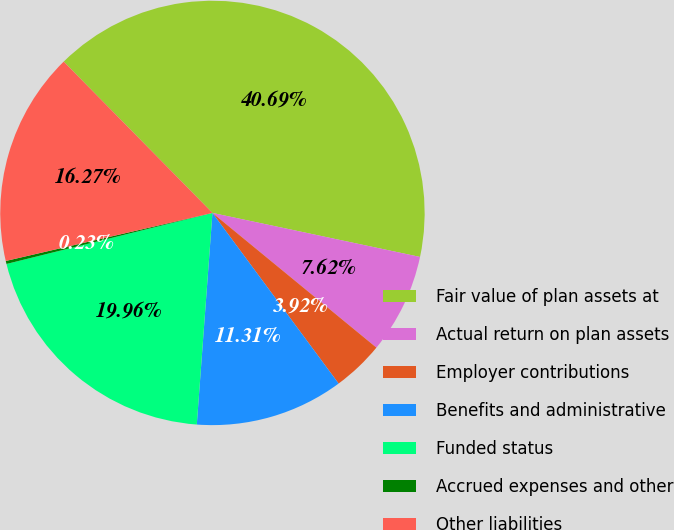<chart> <loc_0><loc_0><loc_500><loc_500><pie_chart><fcel>Fair value of plan assets at<fcel>Actual return on plan assets<fcel>Employer contributions<fcel>Benefits and administrative<fcel>Funded status<fcel>Accrued expenses and other<fcel>Other liabilities<nl><fcel>40.69%<fcel>7.62%<fcel>3.92%<fcel>11.31%<fcel>19.96%<fcel>0.23%<fcel>16.27%<nl></chart> 